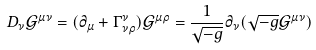Convert formula to latex. <formula><loc_0><loc_0><loc_500><loc_500>D _ { \nu } \mathcal { G } ^ { \mu \nu } = ( \partial _ { \mu } + \Gamma ^ { \nu } _ { \nu \rho } ) \mathcal { G } ^ { \mu \rho } = \frac { 1 } { \sqrt { - g } } \partial _ { \nu } ( \sqrt { - g } \mathcal { G } ^ { \mu \nu } )</formula> 